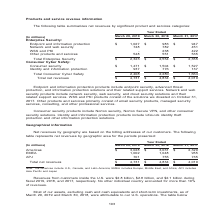According to Nortonlifelock's financial document, What do Endpoint and information protection products include? endpoint security, advanced threat protection, and information protection solutions and their related support services. The document states: "point and information protection products include endpoint security, advanced threat protection, and information protection solutions and their relate..." Also, What does Consumer security products include? Norton security, Norton Secure VPN, and other consumer security solutions. The document states: "Consumer security products include Norton security, Norton Secure VPN, and other consumer security solutions. Identity and information protection prod..." Also, What is the Total net revenues for year ended march 29, 2019? According to the financial document, $4,731 (in millions). The relevant text states: "Total net revenues $ 4,731 $ 4,834 $ 4,019..." Also, can you calculate: For year ended march 29, 2019, what is Total Enterprise Security expressed as a percentage of Total net revenues? Based on the calculation: 2,323/4,731, the result is 49.1 (percentage). This is based on the information: "Total net revenues $ 4,731 $ 4,834 $ 4,019 Total Enterprise Security $ 2,323 $ 2,554 $ 2,355 Consumer Cyber Safety: Consumer security $ 1,471 $ 1,504 $ 1,527 Identity and infor..." The key data points involved are: 2,323, 4,731. Also, can you calculate: What is the average Total net revenues for the fiscal years 2019, 2018 and 2017? To answer this question, I need to perform calculations using the financial data. The calculation is: (4,731+4,834+4,019)/3, which equals 4528 (in millions). This is based on the information: "Total net revenues $ 4,731 $ 4,834 $ 4,019 Total net revenues $ 4,731 $ 4,834 $ 4,019 Total net revenues $ 4,731 $ 4,834 $ 4,019..." The key data points involved are: 4,019, 4,731, 4,834. Also, can you calculate: For year ended march 29, 2019, what is the difference between  Total Consumer Cyber Safety and Total Enterprise Security? Based on the calculation: 2,408-2,323, the result is 85 (in millions). This is based on the information: "Total Consumer Cyber Safety 2,408 2,280 1,664 Total Enterprise Security $ 2,323 $ 2,554 $ 2,355 Consumer Cyber Safety: Consumer security $ 1,471 $ 1,504 $ 1,527 Identity and infor..." The key data points involved are: 2,323, 2,408. 